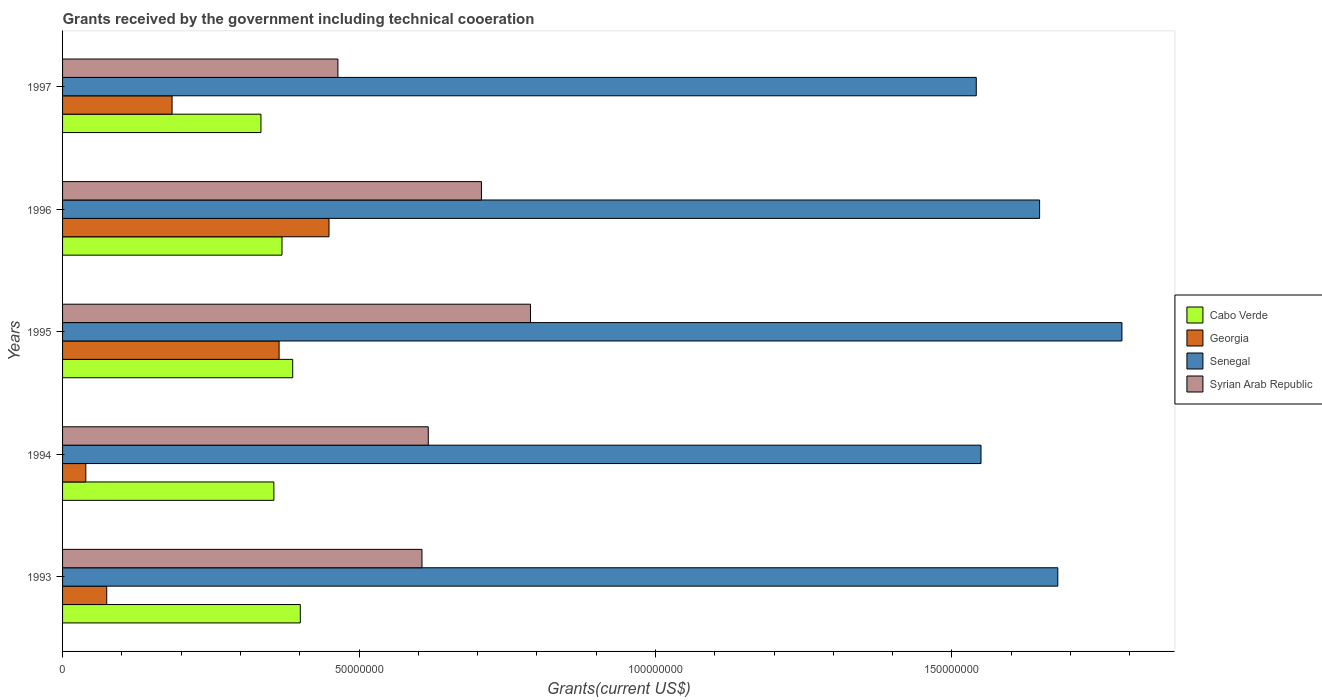Are the number of bars per tick equal to the number of legend labels?
Offer a terse response. Yes. In how many cases, is the number of bars for a given year not equal to the number of legend labels?
Your answer should be very brief. 0. What is the total grants received by the government in Syrian Arab Republic in 1996?
Make the answer very short. 7.06e+07. Across all years, what is the maximum total grants received by the government in Cabo Verde?
Make the answer very short. 4.01e+07. Across all years, what is the minimum total grants received by the government in Cabo Verde?
Offer a very short reply. 3.35e+07. In which year was the total grants received by the government in Georgia minimum?
Your answer should be very brief. 1994. What is the total total grants received by the government in Georgia in the graph?
Your answer should be compact. 1.11e+08. What is the difference between the total grants received by the government in Cabo Verde in 1993 and that in 1997?
Provide a succinct answer. 6.64e+06. What is the difference between the total grants received by the government in Syrian Arab Republic in 1993 and the total grants received by the government in Cabo Verde in 1996?
Offer a terse response. 2.36e+07. What is the average total grants received by the government in Cabo Verde per year?
Your answer should be very brief. 3.70e+07. In the year 1993, what is the difference between the total grants received by the government in Senegal and total grants received by the government in Syrian Arab Republic?
Give a very brief answer. 1.07e+08. In how many years, is the total grants received by the government in Georgia greater than 160000000 US$?
Give a very brief answer. 0. What is the ratio of the total grants received by the government in Senegal in 1994 to that in 1996?
Offer a terse response. 0.94. Is the difference between the total grants received by the government in Senegal in 1995 and 1996 greater than the difference between the total grants received by the government in Syrian Arab Republic in 1995 and 1996?
Keep it short and to the point. Yes. What is the difference between the highest and the second highest total grants received by the government in Cabo Verde?
Keep it short and to the point. 1.28e+06. What is the difference between the highest and the lowest total grants received by the government in Syrian Arab Republic?
Make the answer very short. 3.25e+07. Is it the case that in every year, the sum of the total grants received by the government in Georgia and total grants received by the government in Cabo Verde is greater than the sum of total grants received by the government in Syrian Arab Republic and total grants received by the government in Senegal?
Give a very brief answer. No. What does the 1st bar from the top in 1994 represents?
Offer a very short reply. Syrian Arab Republic. What does the 4th bar from the bottom in 1996 represents?
Keep it short and to the point. Syrian Arab Republic. How many bars are there?
Your response must be concise. 20. How many years are there in the graph?
Make the answer very short. 5. What is the difference between two consecutive major ticks on the X-axis?
Give a very brief answer. 5.00e+07. Are the values on the major ticks of X-axis written in scientific E-notation?
Offer a very short reply. No. Does the graph contain any zero values?
Provide a succinct answer. No. How are the legend labels stacked?
Offer a terse response. Vertical. What is the title of the graph?
Offer a terse response. Grants received by the government including technical cooeration. Does "Indonesia" appear as one of the legend labels in the graph?
Offer a very short reply. No. What is the label or title of the X-axis?
Offer a terse response. Grants(current US$). What is the Grants(current US$) of Cabo Verde in 1993?
Make the answer very short. 4.01e+07. What is the Grants(current US$) of Georgia in 1993?
Give a very brief answer. 7.45e+06. What is the Grants(current US$) of Senegal in 1993?
Provide a succinct answer. 1.68e+08. What is the Grants(current US$) in Syrian Arab Republic in 1993?
Make the answer very short. 6.06e+07. What is the Grants(current US$) in Cabo Verde in 1994?
Offer a terse response. 3.56e+07. What is the Grants(current US$) of Georgia in 1994?
Give a very brief answer. 3.92e+06. What is the Grants(current US$) of Senegal in 1994?
Your response must be concise. 1.55e+08. What is the Grants(current US$) of Syrian Arab Republic in 1994?
Give a very brief answer. 6.17e+07. What is the Grants(current US$) in Cabo Verde in 1995?
Give a very brief answer. 3.88e+07. What is the Grants(current US$) of Georgia in 1995?
Keep it short and to the point. 3.65e+07. What is the Grants(current US$) of Senegal in 1995?
Your answer should be very brief. 1.79e+08. What is the Grants(current US$) in Syrian Arab Republic in 1995?
Your answer should be very brief. 7.89e+07. What is the Grants(current US$) of Cabo Verde in 1996?
Keep it short and to the point. 3.70e+07. What is the Grants(current US$) of Georgia in 1996?
Provide a short and direct response. 4.49e+07. What is the Grants(current US$) in Senegal in 1996?
Give a very brief answer. 1.65e+08. What is the Grants(current US$) in Syrian Arab Republic in 1996?
Keep it short and to the point. 7.06e+07. What is the Grants(current US$) in Cabo Verde in 1997?
Your response must be concise. 3.35e+07. What is the Grants(current US$) in Georgia in 1997?
Your response must be concise. 1.85e+07. What is the Grants(current US$) of Senegal in 1997?
Your answer should be compact. 1.54e+08. What is the Grants(current US$) of Syrian Arab Republic in 1997?
Ensure brevity in your answer.  4.64e+07. Across all years, what is the maximum Grants(current US$) of Cabo Verde?
Make the answer very short. 4.01e+07. Across all years, what is the maximum Grants(current US$) of Georgia?
Your answer should be compact. 4.49e+07. Across all years, what is the maximum Grants(current US$) of Senegal?
Offer a terse response. 1.79e+08. Across all years, what is the maximum Grants(current US$) of Syrian Arab Republic?
Provide a succinct answer. 7.89e+07. Across all years, what is the minimum Grants(current US$) of Cabo Verde?
Your answer should be compact. 3.35e+07. Across all years, what is the minimum Grants(current US$) in Georgia?
Give a very brief answer. 3.92e+06. Across all years, what is the minimum Grants(current US$) of Senegal?
Give a very brief answer. 1.54e+08. Across all years, what is the minimum Grants(current US$) of Syrian Arab Republic?
Offer a very short reply. 4.64e+07. What is the total Grants(current US$) of Cabo Verde in the graph?
Provide a succinct answer. 1.85e+08. What is the total Grants(current US$) of Georgia in the graph?
Offer a very short reply. 1.11e+08. What is the total Grants(current US$) in Senegal in the graph?
Provide a short and direct response. 8.20e+08. What is the total Grants(current US$) of Syrian Arab Republic in the graph?
Provide a short and direct response. 3.18e+08. What is the difference between the Grants(current US$) in Cabo Verde in 1993 and that in 1994?
Provide a succinct answer. 4.46e+06. What is the difference between the Grants(current US$) in Georgia in 1993 and that in 1994?
Ensure brevity in your answer.  3.53e+06. What is the difference between the Grants(current US$) in Senegal in 1993 and that in 1994?
Ensure brevity in your answer.  1.30e+07. What is the difference between the Grants(current US$) of Syrian Arab Republic in 1993 and that in 1994?
Offer a very short reply. -1.06e+06. What is the difference between the Grants(current US$) in Cabo Verde in 1993 and that in 1995?
Keep it short and to the point. 1.28e+06. What is the difference between the Grants(current US$) of Georgia in 1993 and that in 1995?
Give a very brief answer. -2.91e+07. What is the difference between the Grants(current US$) of Senegal in 1993 and that in 1995?
Provide a short and direct response. -1.08e+07. What is the difference between the Grants(current US$) of Syrian Arab Republic in 1993 and that in 1995?
Offer a terse response. -1.83e+07. What is the difference between the Grants(current US$) in Cabo Verde in 1993 and that in 1996?
Ensure brevity in your answer.  3.09e+06. What is the difference between the Grants(current US$) of Georgia in 1993 and that in 1996?
Keep it short and to the point. -3.75e+07. What is the difference between the Grants(current US$) in Senegal in 1993 and that in 1996?
Offer a terse response. 3.07e+06. What is the difference between the Grants(current US$) in Syrian Arab Republic in 1993 and that in 1996?
Provide a short and direct response. -1.00e+07. What is the difference between the Grants(current US$) in Cabo Verde in 1993 and that in 1997?
Keep it short and to the point. 6.64e+06. What is the difference between the Grants(current US$) of Georgia in 1993 and that in 1997?
Your answer should be very brief. -1.10e+07. What is the difference between the Grants(current US$) of Senegal in 1993 and that in 1997?
Your answer should be very brief. 1.38e+07. What is the difference between the Grants(current US$) of Syrian Arab Republic in 1993 and that in 1997?
Offer a very short reply. 1.42e+07. What is the difference between the Grants(current US$) in Cabo Verde in 1994 and that in 1995?
Provide a succinct answer. -3.18e+06. What is the difference between the Grants(current US$) of Georgia in 1994 and that in 1995?
Make the answer very short. -3.26e+07. What is the difference between the Grants(current US$) in Senegal in 1994 and that in 1995?
Provide a short and direct response. -2.38e+07. What is the difference between the Grants(current US$) of Syrian Arab Republic in 1994 and that in 1995?
Offer a very short reply. -1.72e+07. What is the difference between the Grants(current US$) of Cabo Verde in 1994 and that in 1996?
Make the answer very short. -1.37e+06. What is the difference between the Grants(current US$) in Georgia in 1994 and that in 1996?
Make the answer very short. -4.10e+07. What is the difference between the Grants(current US$) in Senegal in 1994 and that in 1996?
Offer a very short reply. -9.88e+06. What is the difference between the Grants(current US$) of Syrian Arab Republic in 1994 and that in 1996?
Your response must be concise. -8.97e+06. What is the difference between the Grants(current US$) of Cabo Verde in 1994 and that in 1997?
Offer a terse response. 2.18e+06. What is the difference between the Grants(current US$) in Georgia in 1994 and that in 1997?
Keep it short and to the point. -1.46e+07. What is the difference between the Grants(current US$) of Senegal in 1994 and that in 1997?
Give a very brief answer. 8.00e+05. What is the difference between the Grants(current US$) in Syrian Arab Republic in 1994 and that in 1997?
Keep it short and to the point. 1.52e+07. What is the difference between the Grants(current US$) in Cabo Verde in 1995 and that in 1996?
Offer a terse response. 1.81e+06. What is the difference between the Grants(current US$) of Georgia in 1995 and that in 1996?
Your response must be concise. -8.42e+06. What is the difference between the Grants(current US$) in Senegal in 1995 and that in 1996?
Your answer should be compact. 1.39e+07. What is the difference between the Grants(current US$) of Syrian Arab Republic in 1995 and that in 1996?
Your answer should be very brief. 8.27e+06. What is the difference between the Grants(current US$) of Cabo Verde in 1995 and that in 1997?
Make the answer very short. 5.36e+06. What is the difference between the Grants(current US$) of Georgia in 1995 and that in 1997?
Offer a very short reply. 1.80e+07. What is the difference between the Grants(current US$) of Senegal in 1995 and that in 1997?
Your answer should be very brief. 2.46e+07. What is the difference between the Grants(current US$) in Syrian Arab Republic in 1995 and that in 1997?
Ensure brevity in your answer.  3.25e+07. What is the difference between the Grants(current US$) of Cabo Verde in 1996 and that in 1997?
Keep it short and to the point. 3.55e+06. What is the difference between the Grants(current US$) in Georgia in 1996 and that in 1997?
Provide a short and direct response. 2.65e+07. What is the difference between the Grants(current US$) in Senegal in 1996 and that in 1997?
Keep it short and to the point. 1.07e+07. What is the difference between the Grants(current US$) in Syrian Arab Republic in 1996 and that in 1997?
Your answer should be compact. 2.42e+07. What is the difference between the Grants(current US$) of Cabo Verde in 1993 and the Grants(current US$) of Georgia in 1994?
Provide a short and direct response. 3.62e+07. What is the difference between the Grants(current US$) in Cabo Verde in 1993 and the Grants(current US$) in Senegal in 1994?
Your answer should be compact. -1.15e+08. What is the difference between the Grants(current US$) in Cabo Verde in 1993 and the Grants(current US$) in Syrian Arab Republic in 1994?
Keep it short and to the point. -2.16e+07. What is the difference between the Grants(current US$) of Georgia in 1993 and the Grants(current US$) of Senegal in 1994?
Your answer should be very brief. -1.47e+08. What is the difference between the Grants(current US$) of Georgia in 1993 and the Grants(current US$) of Syrian Arab Republic in 1994?
Make the answer very short. -5.42e+07. What is the difference between the Grants(current US$) in Senegal in 1993 and the Grants(current US$) in Syrian Arab Republic in 1994?
Ensure brevity in your answer.  1.06e+08. What is the difference between the Grants(current US$) in Cabo Verde in 1993 and the Grants(current US$) in Georgia in 1995?
Your answer should be very brief. 3.58e+06. What is the difference between the Grants(current US$) of Cabo Verde in 1993 and the Grants(current US$) of Senegal in 1995?
Ensure brevity in your answer.  -1.39e+08. What is the difference between the Grants(current US$) in Cabo Verde in 1993 and the Grants(current US$) in Syrian Arab Republic in 1995?
Your answer should be compact. -3.88e+07. What is the difference between the Grants(current US$) in Georgia in 1993 and the Grants(current US$) in Senegal in 1995?
Give a very brief answer. -1.71e+08. What is the difference between the Grants(current US$) of Georgia in 1993 and the Grants(current US$) of Syrian Arab Republic in 1995?
Make the answer very short. -7.15e+07. What is the difference between the Grants(current US$) in Senegal in 1993 and the Grants(current US$) in Syrian Arab Republic in 1995?
Your answer should be very brief. 8.89e+07. What is the difference between the Grants(current US$) in Cabo Verde in 1993 and the Grants(current US$) in Georgia in 1996?
Make the answer very short. -4.84e+06. What is the difference between the Grants(current US$) of Cabo Verde in 1993 and the Grants(current US$) of Senegal in 1996?
Provide a succinct answer. -1.25e+08. What is the difference between the Grants(current US$) of Cabo Verde in 1993 and the Grants(current US$) of Syrian Arab Republic in 1996?
Make the answer very short. -3.06e+07. What is the difference between the Grants(current US$) of Georgia in 1993 and the Grants(current US$) of Senegal in 1996?
Give a very brief answer. -1.57e+08. What is the difference between the Grants(current US$) of Georgia in 1993 and the Grants(current US$) of Syrian Arab Republic in 1996?
Your answer should be compact. -6.32e+07. What is the difference between the Grants(current US$) in Senegal in 1993 and the Grants(current US$) in Syrian Arab Republic in 1996?
Provide a short and direct response. 9.72e+07. What is the difference between the Grants(current US$) in Cabo Verde in 1993 and the Grants(current US$) in Georgia in 1997?
Provide a short and direct response. 2.16e+07. What is the difference between the Grants(current US$) in Cabo Verde in 1993 and the Grants(current US$) in Senegal in 1997?
Provide a succinct answer. -1.14e+08. What is the difference between the Grants(current US$) of Cabo Verde in 1993 and the Grants(current US$) of Syrian Arab Republic in 1997?
Give a very brief answer. -6.34e+06. What is the difference between the Grants(current US$) in Georgia in 1993 and the Grants(current US$) in Senegal in 1997?
Your answer should be very brief. -1.47e+08. What is the difference between the Grants(current US$) in Georgia in 1993 and the Grants(current US$) in Syrian Arab Republic in 1997?
Your answer should be very brief. -3.90e+07. What is the difference between the Grants(current US$) in Senegal in 1993 and the Grants(current US$) in Syrian Arab Republic in 1997?
Your answer should be very brief. 1.21e+08. What is the difference between the Grants(current US$) in Cabo Verde in 1994 and the Grants(current US$) in Georgia in 1995?
Your response must be concise. -8.80e+05. What is the difference between the Grants(current US$) of Cabo Verde in 1994 and the Grants(current US$) of Senegal in 1995?
Make the answer very short. -1.43e+08. What is the difference between the Grants(current US$) in Cabo Verde in 1994 and the Grants(current US$) in Syrian Arab Republic in 1995?
Give a very brief answer. -4.33e+07. What is the difference between the Grants(current US$) in Georgia in 1994 and the Grants(current US$) in Senegal in 1995?
Your answer should be compact. -1.75e+08. What is the difference between the Grants(current US$) of Georgia in 1994 and the Grants(current US$) of Syrian Arab Republic in 1995?
Make the answer very short. -7.50e+07. What is the difference between the Grants(current US$) of Senegal in 1994 and the Grants(current US$) of Syrian Arab Republic in 1995?
Give a very brief answer. 7.60e+07. What is the difference between the Grants(current US$) in Cabo Verde in 1994 and the Grants(current US$) in Georgia in 1996?
Provide a succinct answer. -9.30e+06. What is the difference between the Grants(current US$) of Cabo Verde in 1994 and the Grants(current US$) of Senegal in 1996?
Your answer should be very brief. -1.29e+08. What is the difference between the Grants(current US$) of Cabo Verde in 1994 and the Grants(current US$) of Syrian Arab Republic in 1996?
Your answer should be very brief. -3.50e+07. What is the difference between the Grants(current US$) of Georgia in 1994 and the Grants(current US$) of Senegal in 1996?
Make the answer very short. -1.61e+08. What is the difference between the Grants(current US$) in Georgia in 1994 and the Grants(current US$) in Syrian Arab Republic in 1996?
Provide a short and direct response. -6.67e+07. What is the difference between the Grants(current US$) of Senegal in 1994 and the Grants(current US$) of Syrian Arab Republic in 1996?
Ensure brevity in your answer.  8.43e+07. What is the difference between the Grants(current US$) of Cabo Verde in 1994 and the Grants(current US$) of Georgia in 1997?
Ensure brevity in your answer.  1.72e+07. What is the difference between the Grants(current US$) of Cabo Verde in 1994 and the Grants(current US$) of Senegal in 1997?
Keep it short and to the point. -1.18e+08. What is the difference between the Grants(current US$) in Cabo Verde in 1994 and the Grants(current US$) in Syrian Arab Republic in 1997?
Your answer should be compact. -1.08e+07. What is the difference between the Grants(current US$) in Georgia in 1994 and the Grants(current US$) in Senegal in 1997?
Your answer should be compact. -1.50e+08. What is the difference between the Grants(current US$) in Georgia in 1994 and the Grants(current US$) in Syrian Arab Republic in 1997?
Keep it short and to the point. -4.25e+07. What is the difference between the Grants(current US$) in Senegal in 1994 and the Grants(current US$) in Syrian Arab Republic in 1997?
Ensure brevity in your answer.  1.08e+08. What is the difference between the Grants(current US$) in Cabo Verde in 1995 and the Grants(current US$) in Georgia in 1996?
Provide a short and direct response. -6.12e+06. What is the difference between the Grants(current US$) of Cabo Verde in 1995 and the Grants(current US$) of Senegal in 1996?
Your answer should be very brief. -1.26e+08. What is the difference between the Grants(current US$) of Cabo Verde in 1995 and the Grants(current US$) of Syrian Arab Republic in 1996?
Give a very brief answer. -3.18e+07. What is the difference between the Grants(current US$) of Georgia in 1995 and the Grants(current US$) of Senegal in 1996?
Keep it short and to the point. -1.28e+08. What is the difference between the Grants(current US$) of Georgia in 1995 and the Grants(current US$) of Syrian Arab Republic in 1996?
Offer a very short reply. -3.41e+07. What is the difference between the Grants(current US$) of Senegal in 1995 and the Grants(current US$) of Syrian Arab Republic in 1996?
Make the answer very short. 1.08e+08. What is the difference between the Grants(current US$) in Cabo Verde in 1995 and the Grants(current US$) in Georgia in 1997?
Offer a very short reply. 2.04e+07. What is the difference between the Grants(current US$) of Cabo Verde in 1995 and the Grants(current US$) of Senegal in 1997?
Give a very brief answer. -1.15e+08. What is the difference between the Grants(current US$) in Cabo Verde in 1995 and the Grants(current US$) in Syrian Arab Republic in 1997?
Provide a short and direct response. -7.62e+06. What is the difference between the Grants(current US$) of Georgia in 1995 and the Grants(current US$) of Senegal in 1997?
Offer a terse response. -1.18e+08. What is the difference between the Grants(current US$) of Georgia in 1995 and the Grants(current US$) of Syrian Arab Republic in 1997?
Offer a very short reply. -9.92e+06. What is the difference between the Grants(current US$) of Senegal in 1995 and the Grants(current US$) of Syrian Arab Republic in 1997?
Provide a short and direct response. 1.32e+08. What is the difference between the Grants(current US$) in Cabo Verde in 1996 and the Grants(current US$) in Georgia in 1997?
Provide a short and direct response. 1.85e+07. What is the difference between the Grants(current US$) of Cabo Verde in 1996 and the Grants(current US$) of Senegal in 1997?
Give a very brief answer. -1.17e+08. What is the difference between the Grants(current US$) of Cabo Verde in 1996 and the Grants(current US$) of Syrian Arab Republic in 1997?
Give a very brief answer. -9.43e+06. What is the difference between the Grants(current US$) in Georgia in 1996 and the Grants(current US$) in Senegal in 1997?
Give a very brief answer. -1.09e+08. What is the difference between the Grants(current US$) in Georgia in 1996 and the Grants(current US$) in Syrian Arab Republic in 1997?
Your answer should be compact. -1.50e+06. What is the difference between the Grants(current US$) of Senegal in 1996 and the Grants(current US$) of Syrian Arab Republic in 1997?
Your answer should be very brief. 1.18e+08. What is the average Grants(current US$) of Cabo Verde per year?
Your response must be concise. 3.70e+07. What is the average Grants(current US$) in Georgia per year?
Give a very brief answer. 2.23e+07. What is the average Grants(current US$) of Senegal per year?
Provide a short and direct response. 1.64e+08. What is the average Grants(current US$) in Syrian Arab Republic per year?
Offer a very short reply. 6.37e+07. In the year 1993, what is the difference between the Grants(current US$) of Cabo Verde and Grants(current US$) of Georgia?
Offer a very short reply. 3.26e+07. In the year 1993, what is the difference between the Grants(current US$) of Cabo Verde and Grants(current US$) of Senegal?
Your response must be concise. -1.28e+08. In the year 1993, what is the difference between the Grants(current US$) of Cabo Verde and Grants(current US$) of Syrian Arab Republic?
Give a very brief answer. -2.05e+07. In the year 1993, what is the difference between the Grants(current US$) of Georgia and Grants(current US$) of Senegal?
Give a very brief answer. -1.60e+08. In the year 1993, what is the difference between the Grants(current US$) of Georgia and Grants(current US$) of Syrian Arab Republic?
Keep it short and to the point. -5.32e+07. In the year 1993, what is the difference between the Grants(current US$) in Senegal and Grants(current US$) in Syrian Arab Republic?
Your answer should be compact. 1.07e+08. In the year 1994, what is the difference between the Grants(current US$) in Cabo Verde and Grants(current US$) in Georgia?
Provide a succinct answer. 3.17e+07. In the year 1994, what is the difference between the Grants(current US$) in Cabo Verde and Grants(current US$) in Senegal?
Your answer should be compact. -1.19e+08. In the year 1994, what is the difference between the Grants(current US$) in Cabo Verde and Grants(current US$) in Syrian Arab Republic?
Give a very brief answer. -2.60e+07. In the year 1994, what is the difference between the Grants(current US$) in Georgia and Grants(current US$) in Senegal?
Your response must be concise. -1.51e+08. In the year 1994, what is the difference between the Grants(current US$) in Georgia and Grants(current US$) in Syrian Arab Republic?
Your answer should be compact. -5.78e+07. In the year 1994, what is the difference between the Grants(current US$) of Senegal and Grants(current US$) of Syrian Arab Republic?
Give a very brief answer. 9.32e+07. In the year 1995, what is the difference between the Grants(current US$) of Cabo Verde and Grants(current US$) of Georgia?
Provide a short and direct response. 2.30e+06. In the year 1995, what is the difference between the Grants(current US$) of Cabo Verde and Grants(current US$) of Senegal?
Your answer should be very brief. -1.40e+08. In the year 1995, what is the difference between the Grants(current US$) of Cabo Verde and Grants(current US$) of Syrian Arab Republic?
Offer a terse response. -4.01e+07. In the year 1995, what is the difference between the Grants(current US$) of Georgia and Grants(current US$) of Senegal?
Offer a very short reply. -1.42e+08. In the year 1995, what is the difference between the Grants(current US$) of Georgia and Grants(current US$) of Syrian Arab Republic?
Make the answer very short. -4.24e+07. In the year 1995, what is the difference between the Grants(current US$) in Senegal and Grants(current US$) in Syrian Arab Republic?
Your response must be concise. 9.98e+07. In the year 1996, what is the difference between the Grants(current US$) in Cabo Verde and Grants(current US$) in Georgia?
Ensure brevity in your answer.  -7.93e+06. In the year 1996, what is the difference between the Grants(current US$) in Cabo Verde and Grants(current US$) in Senegal?
Your answer should be compact. -1.28e+08. In the year 1996, what is the difference between the Grants(current US$) of Cabo Verde and Grants(current US$) of Syrian Arab Republic?
Offer a very short reply. -3.36e+07. In the year 1996, what is the difference between the Grants(current US$) of Georgia and Grants(current US$) of Senegal?
Provide a succinct answer. -1.20e+08. In the year 1996, what is the difference between the Grants(current US$) in Georgia and Grants(current US$) in Syrian Arab Republic?
Keep it short and to the point. -2.57e+07. In the year 1996, what is the difference between the Grants(current US$) in Senegal and Grants(current US$) in Syrian Arab Republic?
Offer a very short reply. 9.41e+07. In the year 1997, what is the difference between the Grants(current US$) in Cabo Verde and Grants(current US$) in Georgia?
Your answer should be very brief. 1.50e+07. In the year 1997, what is the difference between the Grants(current US$) in Cabo Verde and Grants(current US$) in Senegal?
Provide a succinct answer. -1.21e+08. In the year 1997, what is the difference between the Grants(current US$) of Cabo Verde and Grants(current US$) of Syrian Arab Republic?
Offer a very short reply. -1.30e+07. In the year 1997, what is the difference between the Grants(current US$) in Georgia and Grants(current US$) in Senegal?
Provide a short and direct response. -1.36e+08. In the year 1997, what is the difference between the Grants(current US$) in Georgia and Grants(current US$) in Syrian Arab Republic?
Your answer should be very brief. -2.80e+07. In the year 1997, what is the difference between the Grants(current US$) in Senegal and Grants(current US$) in Syrian Arab Republic?
Provide a succinct answer. 1.08e+08. What is the ratio of the Grants(current US$) of Cabo Verde in 1993 to that in 1994?
Give a very brief answer. 1.13. What is the ratio of the Grants(current US$) of Georgia in 1993 to that in 1994?
Your answer should be compact. 1.9. What is the ratio of the Grants(current US$) of Senegal in 1993 to that in 1994?
Make the answer very short. 1.08. What is the ratio of the Grants(current US$) of Syrian Arab Republic in 1993 to that in 1994?
Offer a very short reply. 0.98. What is the ratio of the Grants(current US$) of Cabo Verde in 1993 to that in 1995?
Offer a terse response. 1.03. What is the ratio of the Grants(current US$) of Georgia in 1993 to that in 1995?
Make the answer very short. 0.2. What is the ratio of the Grants(current US$) of Senegal in 1993 to that in 1995?
Keep it short and to the point. 0.94. What is the ratio of the Grants(current US$) of Syrian Arab Republic in 1993 to that in 1995?
Provide a short and direct response. 0.77. What is the ratio of the Grants(current US$) in Cabo Verde in 1993 to that in 1996?
Make the answer very short. 1.08. What is the ratio of the Grants(current US$) in Georgia in 1993 to that in 1996?
Provide a succinct answer. 0.17. What is the ratio of the Grants(current US$) in Senegal in 1993 to that in 1996?
Provide a short and direct response. 1.02. What is the ratio of the Grants(current US$) in Syrian Arab Republic in 1993 to that in 1996?
Give a very brief answer. 0.86. What is the ratio of the Grants(current US$) in Cabo Verde in 1993 to that in 1997?
Make the answer very short. 1.2. What is the ratio of the Grants(current US$) in Georgia in 1993 to that in 1997?
Offer a terse response. 0.4. What is the ratio of the Grants(current US$) of Senegal in 1993 to that in 1997?
Your answer should be very brief. 1.09. What is the ratio of the Grants(current US$) of Syrian Arab Republic in 1993 to that in 1997?
Provide a short and direct response. 1.31. What is the ratio of the Grants(current US$) in Cabo Verde in 1994 to that in 1995?
Give a very brief answer. 0.92. What is the ratio of the Grants(current US$) of Georgia in 1994 to that in 1995?
Provide a succinct answer. 0.11. What is the ratio of the Grants(current US$) of Senegal in 1994 to that in 1995?
Keep it short and to the point. 0.87. What is the ratio of the Grants(current US$) in Syrian Arab Republic in 1994 to that in 1995?
Offer a very short reply. 0.78. What is the ratio of the Grants(current US$) in Cabo Verde in 1994 to that in 1996?
Offer a very short reply. 0.96. What is the ratio of the Grants(current US$) in Georgia in 1994 to that in 1996?
Provide a short and direct response. 0.09. What is the ratio of the Grants(current US$) of Syrian Arab Republic in 1994 to that in 1996?
Your answer should be very brief. 0.87. What is the ratio of the Grants(current US$) in Cabo Verde in 1994 to that in 1997?
Your response must be concise. 1.07. What is the ratio of the Grants(current US$) in Georgia in 1994 to that in 1997?
Give a very brief answer. 0.21. What is the ratio of the Grants(current US$) in Syrian Arab Republic in 1994 to that in 1997?
Your answer should be compact. 1.33. What is the ratio of the Grants(current US$) of Cabo Verde in 1995 to that in 1996?
Your answer should be compact. 1.05. What is the ratio of the Grants(current US$) of Georgia in 1995 to that in 1996?
Give a very brief answer. 0.81. What is the ratio of the Grants(current US$) in Senegal in 1995 to that in 1996?
Your answer should be very brief. 1.08. What is the ratio of the Grants(current US$) in Syrian Arab Republic in 1995 to that in 1996?
Provide a short and direct response. 1.12. What is the ratio of the Grants(current US$) in Cabo Verde in 1995 to that in 1997?
Keep it short and to the point. 1.16. What is the ratio of the Grants(current US$) in Georgia in 1995 to that in 1997?
Offer a very short reply. 1.98. What is the ratio of the Grants(current US$) of Senegal in 1995 to that in 1997?
Offer a terse response. 1.16. What is the ratio of the Grants(current US$) in Syrian Arab Republic in 1995 to that in 1997?
Your response must be concise. 1.7. What is the ratio of the Grants(current US$) of Cabo Verde in 1996 to that in 1997?
Your answer should be very brief. 1.11. What is the ratio of the Grants(current US$) in Georgia in 1996 to that in 1997?
Your response must be concise. 2.43. What is the ratio of the Grants(current US$) in Senegal in 1996 to that in 1997?
Offer a terse response. 1.07. What is the ratio of the Grants(current US$) of Syrian Arab Republic in 1996 to that in 1997?
Ensure brevity in your answer.  1.52. What is the difference between the highest and the second highest Grants(current US$) of Cabo Verde?
Make the answer very short. 1.28e+06. What is the difference between the highest and the second highest Grants(current US$) in Georgia?
Provide a succinct answer. 8.42e+06. What is the difference between the highest and the second highest Grants(current US$) in Senegal?
Your response must be concise. 1.08e+07. What is the difference between the highest and the second highest Grants(current US$) in Syrian Arab Republic?
Make the answer very short. 8.27e+06. What is the difference between the highest and the lowest Grants(current US$) in Cabo Verde?
Your answer should be compact. 6.64e+06. What is the difference between the highest and the lowest Grants(current US$) in Georgia?
Your answer should be very brief. 4.10e+07. What is the difference between the highest and the lowest Grants(current US$) in Senegal?
Your answer should be compact. 2.46e+07. What is the difference between the highest and the lowest Grants(current US$) in Syrian Arab Republic?
Make the answer very short. 3.25e+07. 